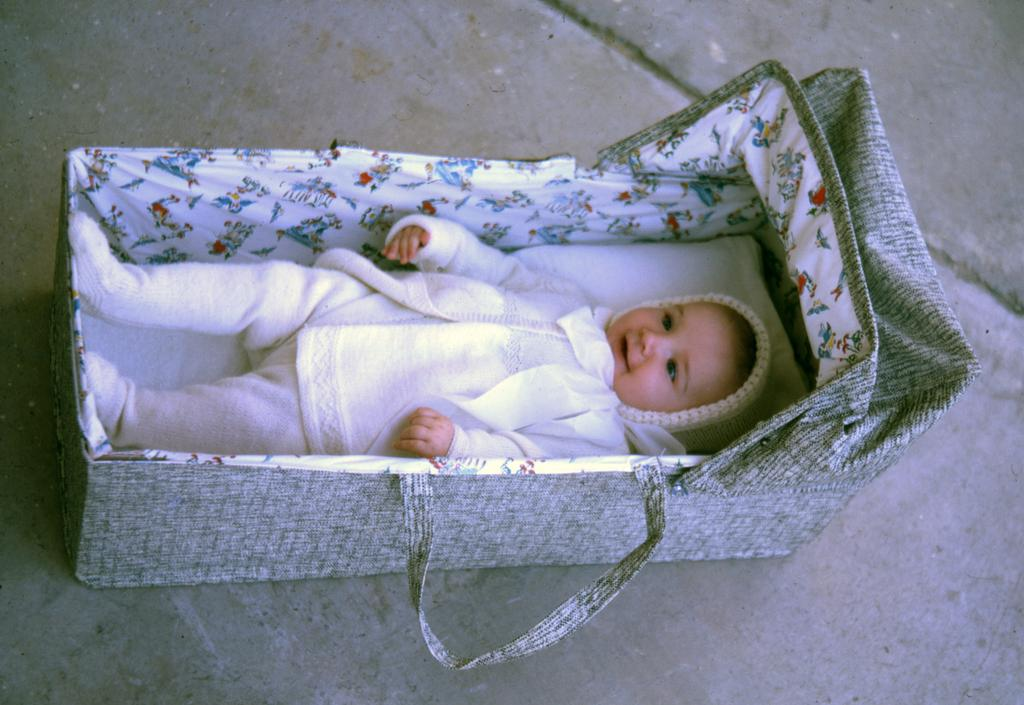What is the main subject of the image? The main subject of the image is a small baby. Where is the baby located in the image? The baby is in a basket. Can you describe the position of the basket in the image? The basket is in the foreground of the image. What type of waste can be seen being disposed of at the edge of the image? There is no waste or disposal activity present in the image. What type of eggnog is being served to the baby in the image? There is no eggnog or any food or drink visible in the image. 